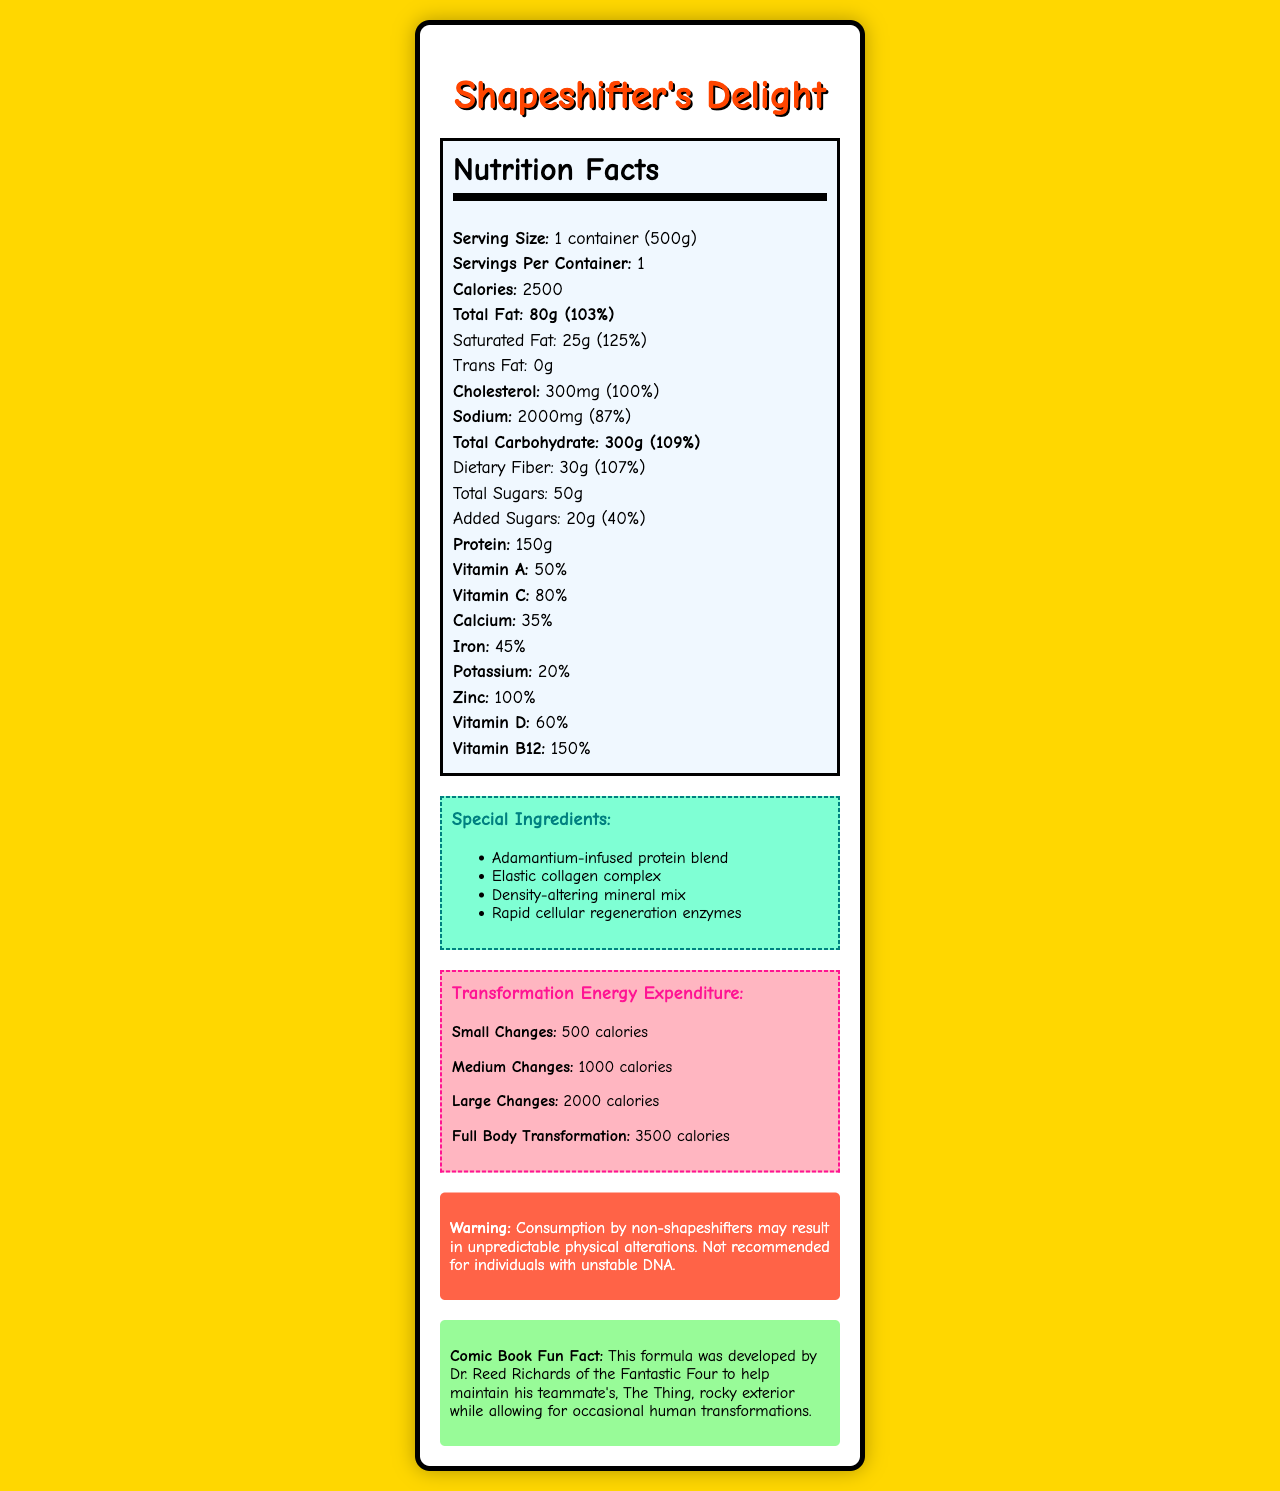what is the serving size? It is mentioned in the Nutrition Facts section under "Serving Size".
Answer: 1 container (500g) how many calories are in one serving of Shapeshifter's Delight? This information is provided in the Nutrition Facts section under "Calories".
Answer: 2500 calories how many grams of protein are in Shapeshifter's Delight? The amount of protein is listed in the Nutrition Facts section under "Protein".
Answer: 150g how much cholesterol is in one serving? The cholesterol content is provided in the Nutrition Facts section under "Cholesterol".
Answer: 300mg what is the percentage daily value of vitamin C in Shapeshifter's Delight? This is listed in the Nutrition Facts section under "Vitamin C".
Answer: 80% which of the following is a special ingredient in Shapeshifter's Delight? A. Vibranium peptides B. Adamantium-infused protein blend C. Energy-boosting herbs "Adamantium-infused protein blend" is listed among the special ingredients.
Answer: B how many calories does a large change expenditure in transformation energy? A. 500 calories B. 1000 calories C. 2000 calories D. 3500 calories The document states that large changes require 2000 calories.
Answer: C consuming Shapeshifter's Delight by non-shapeshifters can result in unpredictable physical alterations, true or false? This warning is provided in the document's warning section.
Answer: True what is the recommended daily value percentage of total fat in Shapeshifter's Delight? It is mentioned in the Nutrition Facts section under "Total Fat".
Answer: 103% describe the main idea of the document. The document includes information on serving size, calories, fats, cholesterol, sodium, carbohydrates, protein, vitamins, and specialized ingredients. Additionally, it outlines the energy expenditure for different levels of physical transformation.
Answer: It's a nutrition facts label for a product called Shapeshifter's Delight, detailing its nutritional content, special ingredients, transformation energy expenditure, warnings, and a comic book fun fact. who developed the Shapeshifter's Delight formula? The comic book fun fact mentions that Dr. Reed Richards of the Fantastic Four developed the formula.
Answer: Dr. Reed Richards how many grams of total sugar are in Shapeshifter's Delight? The total sugar content is listed in the Nutrition Facts section.
Answer: 50g 